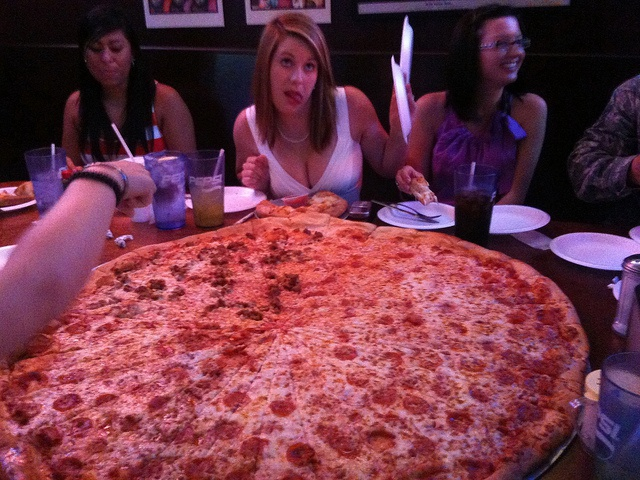Describe the objects in this image and their specific colors. I can see pizza in black, salmon, brown, and maroon tones, people in black, maroon, purple, and brown tones, people in black, purple, and navy tones, people in black, maroon, purple, and navy tones, and people in black, purple, and maroon tones in this image. 